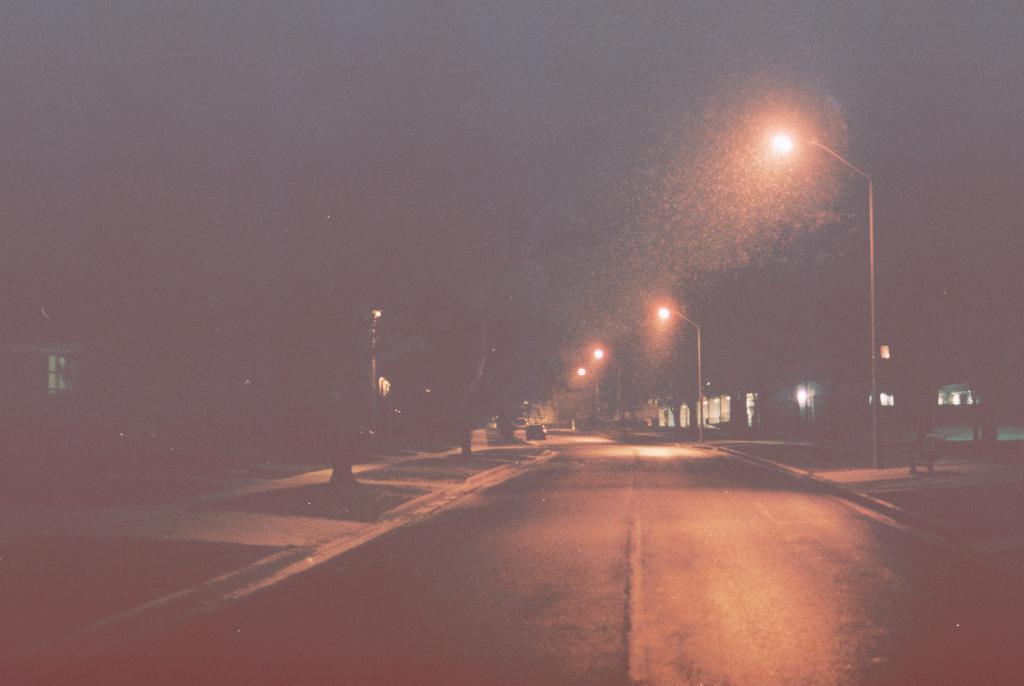What is the main subject in the middle of the picture? There is a road in the middle of the picture. What can be seen on the right side of the picture? There are street lights on the right side of the picture. How would you describe the overall lighting in the image? The background of the image is dark. How many hammers are visible in the image? There are no hammers present in the image. What fact can be learned about the kittens in the image? There are no kittens present in the image, so no fact about them can be learned. 